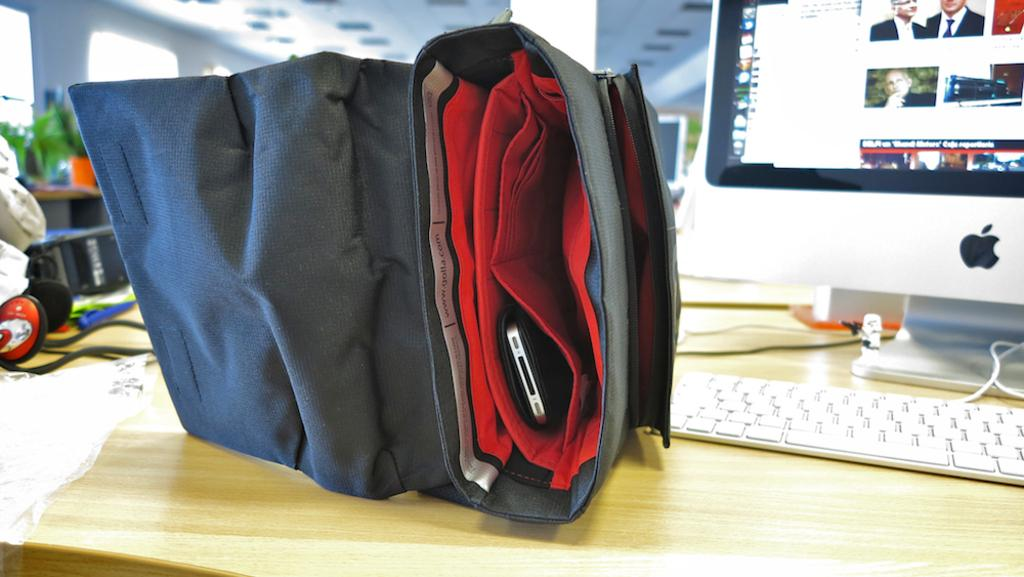What electronic device is visible in the image? There is a computer in the image. What is used to input information into the computer? There is a keyboard in the image. What personal item is stored in the bag in the image? There is a mobile in the bag in the image. What device is used for audio communication in the image? There is a headset on the table in the image. How many trucks are parked outside the building in the image? There is no information about trucks or a building in the image; it only features a computer, keyboard, bag with a mobile, and headset. 